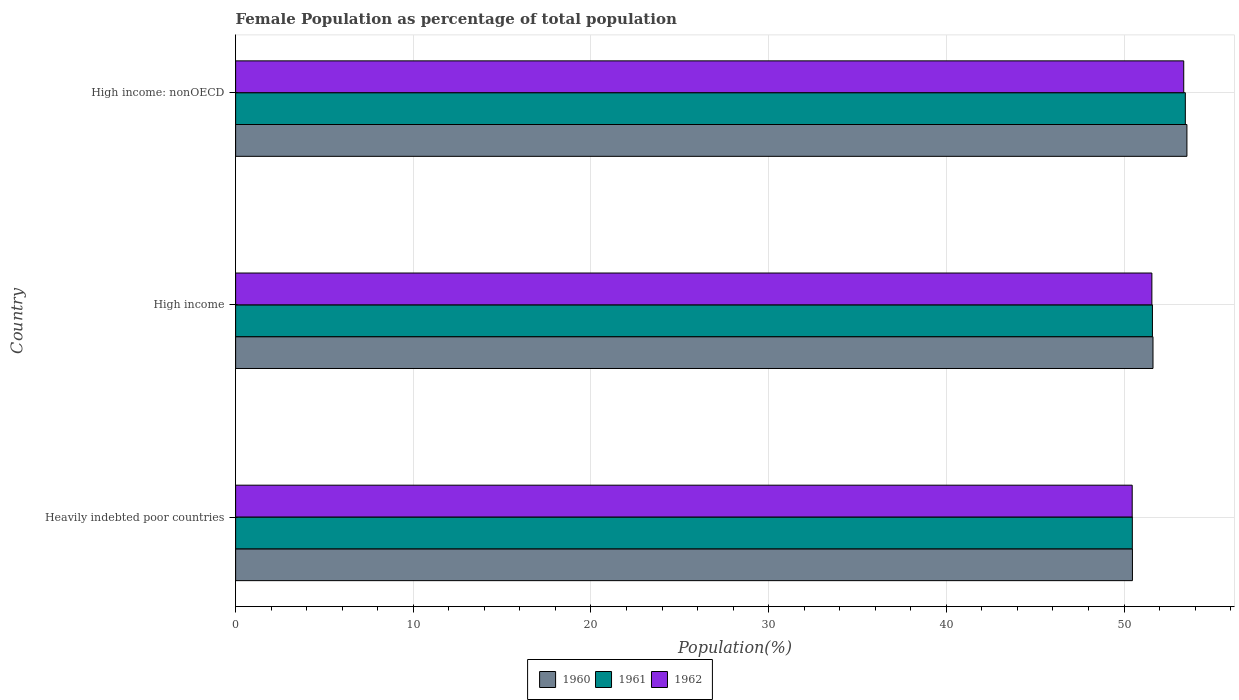Are the number of bars per tick equal to the number of legend labels?
Offer a very short reply. Yes. How many bars are there on the 3rd tick from the top?
Offer a very short reply. 3. What is the label of the 2nd group of bars from the top?
Offer a terse response. High income. What is the female population in in 1960 in Heavily indebted poor countries?
Keep it short and to the point. 50.47. Across all countries, what is the maximum female population in in 1962?
Ensure brevity in your answer.  53.36. Across all countries, what is the minimum female population in in 1961?
Keep it short and to the point. 50.47. In which country was the female population in in 1961 maximum?
Make the answer very short. High income: nonOECD. In which country was the female population in in 1962 minimum?
Offer a terse response. Heavily indebted poor countries. What is the total female population in in 1962 in the graph?
Ensure brevity in your answer.  155.39. What is the difference between the female population in in 1960 in Heavily indebted poor countries and that in High income: nonOECD?
Make the answer very short. -3.07. What is the difference between the female population in in 1960 in Heavily indebted poor countries and the female population in in 1961 in High income?
Provide a succinct answer. -1.13. What is the average female population in in 1960 per country?
Provide a short and direct response. 51.88. What is the difference between the female population in in 1962 and female population in in 1961 in High income?
Your answer should be compact. -0.03. What is the ratio of the female population in in 1961 in Heavily indebted poor countries to that in High income?
Offer a very short reply. 0.98. Is the female population in in 1962 in Heavily indebted poor countries less than that in High income: nonOECD?
Make the answer very short. Yes. What is the difference between the highest and the second highest female population in in 1961?
Keep it short and to the point. 1.85. What is the difference between the highest and the lowest female population in in 1961?
Your response must be concise. 2.98. In how many countries, is the female population in in 1960 greater than the average female population in in 1960 taken over all countries?
Provide a short and direct response. 1. What does the 1st bar from the top in Heavily indebted poor countries represents?
Your response must be concise. 1962. What does the 3rd bar from the bottom in High income represents?
Your answer should be very brief. 1962. Is it the case that in every country, the sum of the female population in in 1962 and female population in in 1960 is greater than the female population in in 1961?
Your response must be concise. Yes. How many bars are there?
Provide a succinct answer. 9. How many countries are there in the graph?
Give a very brief answer. 3. Does the graph contain grids?
Keep it short and to the point. Yes. Where does the legend appear in the graph?
Your answer should be compact. Bottom center. How many legend labels are there?
Your answer should be very brief. 3. What is the title of the graph?
Make the answer very short. Female Population as percentage of total population. Does "2005" appear as one of the legend labels in the graph?
Keep it short and to the point. No. What is the label or title of the X-axis?
Your answer should be very brief. Population(%). What is the Population(%) of 1960 in Heavily indebted poor countries?
Provide a succinct answer. 50.47. What is the Population(%) in 1961 in Heavily indebted poor countries?
Make the answer very short. 50.47. What is the Population(%) in 1962 in Heavily indebted poor countries?
Make the answer very short. 50.46. What is the Population(%) of 1960 in High income?
Your answer should be compact. 51.63. What is the Population(%) of 1961 in High income?
Your response must be concise. 51.6. What is the Population(%) of 1962 in High income?
Your response must be concise. 51.57. What is the Population(%) of 1960 in High income: nonOECD?
Your response must be concise. 53.54. What is the Population(%) in 1961 in High income: nonOECD?
Provide a short and direct response. 53.45. What is the Population(%) in 1962 in High income: nonOECD?
Provide a short and direct response. 53.36. Across all countries, what is the maximum Population(%) in 1960?
Your answer should be very brief. 53.54. Across all countries, what is the maximum Population(%) in 1961?
Make the answer very short. 53.45. Across all countries, what is the maximum Population(%) of 1962?
Offer a very short reply. 53.36. Across all countries, what is the minimum Population(%) of 1960?
Offer a terse response. 50.47. Across all countries, what is the minimum Population(%) of 1961?
Provide a short and direct response. 50.47. Across all countries, what is the minimum Population(%) of 1962?
Your answer should be compact. 50.46. What is the total Population(%) of 1960 in the graph?
Your response must be concise. 155.65. What is the total Population(%) in 1961 in the graph?
Your answer should be very brief. 155.52. What is the total Population(%) of 1962 in the graph?
Your answer should be very brief. 155.39. What is the difference between the Population(%) of 1960 in Heavily indebted poor countries and that in High income?
Provide a succinct answer. -1.16. What is the difference between the Population(%) in 1961 in Heavily indebted poor countries and that in High income?
Provide a succinct answer. -1.13. What is the difference between the Population(%) in 1962 in Heavily indebted poor countries and that in High income?
Provide a short and direct response. -1.11. What is the difference between the Population(%) of 1960 in Heavily indebted poor countries and that in High income: nonOECD?
Your response must be concise. -3.07. What is the difference between the Population(%) in 1961 in Heavily indebted poor countries and that in High income: nonOECD?
Offer a terse response. -2.98. What is the difference between the Population(%) in 1962 in Heavily indebted poor countries and that in High income: nonOECD?
Keep it short and to the point. -2.9. What is the difference between the Population(%) in 1960 in High income and that in High income: nonOECD?
Provide a short and direct response. -1.91. What is the difference between the Population(%) in 1961 in High income and that in High income: nonOECD?
Your answer should be compact. -1.85. What is the difference between the Population(%) in 1962 in High income and that in High income: nonOECD?
Your answer should be very brief. -1.79. What is the difference between the Population(%) of 1960 in Heavily indebted poor countries and the Population(%) of 1961 in High income?
Make the answer very short. -1.13. What is the difference between the Population(%) of 1960 in Heavily indebted poor countries and the Population(%) of 1962 in High income?
Provide a short and direct response. -1.09. What is the difference between the Population(%) of 1961 in Heavily indebted poor countries and the Population(%) of 1962 in High income?
Ensure brevity in your answer.  -1.1. What is the difference between the Population(%) in 1960 in Heavily indebted poor countries and the Population(%) in 1961 in High income: nonOECD?
Give a very brief answer. -2.98. What is the difference between the Population(%) in 1960 in Heavily indebted poor countries and the Population(%) in 1962 in High income: nonOECD?
Offer a very short reply. -2.89. What is the difference between the Population(%) of 1961 in Heavily indebted poor countries and the Population(%) of 1962 in High income: nonOECD?
Give a very brief answer. -2.89. What is the difference between the Population(%) in 1960 in High income and the Population(%) in 1961 in High income: nonOECD?
Provide a succinct answer. -1.82. What is the difference between the Population(%) in 1960 in High income and the Population(%) in 1962 in High income: nonOECD?
Ensure brevity in your answer.  -1.73. What is the difference between the Population(%) of 1961 in High income and the Population(%) of 1962 in High income: nonOECD?
Make the answer very short. -1.76. What is the average Population(%) in 1960 per country?
Your answer should be compact. 51.88. What is the average Population(%) of 1961 per country?
Offer a terse response. 51.84. What is the average Population(%) of 1962 per country?
Your response must be concise. 51.8. What is the difference between the Population(%) of 1960 and Population(%) of 1961 in Heavily indebted poor countries?
Provide a succinct answer. 0.01. What is the difference between the Population(%) of 1960 and Population(%) of 1962 in Heavily indebted poor countries?
Your response must be concise. 0.01. What is the difference between the Population(%) of 1961 and Population(%) of 1962 in Heavily indebted poor countries?
Your response must be concise. 0.01. What is the difference between the Population(%) of 1960 and Population(%) of 1961 in High income?
Your answer should be very brief. 0.03. What is the difference between the Population(%) of 1960 and Population(%) of 1962 in High income?
Provide a succinct answer. 0.06. What is the difference between the Population(%) in 1961 and Population(%) in 1962 in High income?
Provide a succinct answer. 0.03. What is the difference between the Population(%) in 1960 and Population(%) in 1961 in High income: nonOECD?
Offer a very short reply. 0.09. What is the difference between the Population(%) in 1960 and Population(%) in 1962 in High income: nonOECD?
Provide a succinct answer. 0.18. What is the difference between the Population(%) of 1961 and Population(%) of 1962 in High income: nonOECD?
Keep it short and to the point. 0.09. What is the ratio of the Population(%) of 1960 in Heavily indebted poor countries to that in High income?
Offer a terse response. 0.98. What is the ratio of the Population(%) of 1961 in Heavily indebted poor countries to that in High income?
Offer a terse response. 0.98. What is the ratio of the Population(%) of 1962 in Heavily indebted poor countries to that in High income?
Provide a succinct answer. 0.98. What is the ratio of the Population(%) of 1960 in Heavily indebted poor countries to that in High income: nonOECD?
Your answer should be very brief. 0.94. What is the ratio of the Population(%) of 1961 in Heavily indebted poor countries to that in High income: nonOECD?
Offer a very short reply. 0.94. What is the ratio of the Population(%) in 1962 in Heavily indebted poor countries to that in High income: nonOECD?
Offer a very short reply. 0.95. What is the ratio of the Population(%) in 1961 in High income to that in High income: nonOECD?
Your answer should be very brief. 0.97. What is the ratio of the Population(%) of 1962 in High income to that in High income: nonOECD?
Keep it short and to the point. 0.97. What is the difference between the highest and the second highest Population(%) of 1960?
Ensure brevity in your answer.  1.91. What is the difference between the highest and the second highest Population(%) in 1961?
Provide a short and direct response. 1.85. What is the difference between the highest and the second highest Population(%) in 1962?
Make the answer very short. 1.79. What is the difference between the highest and the lowest Population(%) of 1960?
Keep it short and to the point. 3.07. What is the difference between the highest and the lowest Population(%) in 1961?
Make the answer very short. 2.98. What is the difference between the highest and the lowest Population(%) of 1962?
Ensure brevity in your answer.  2.9. 